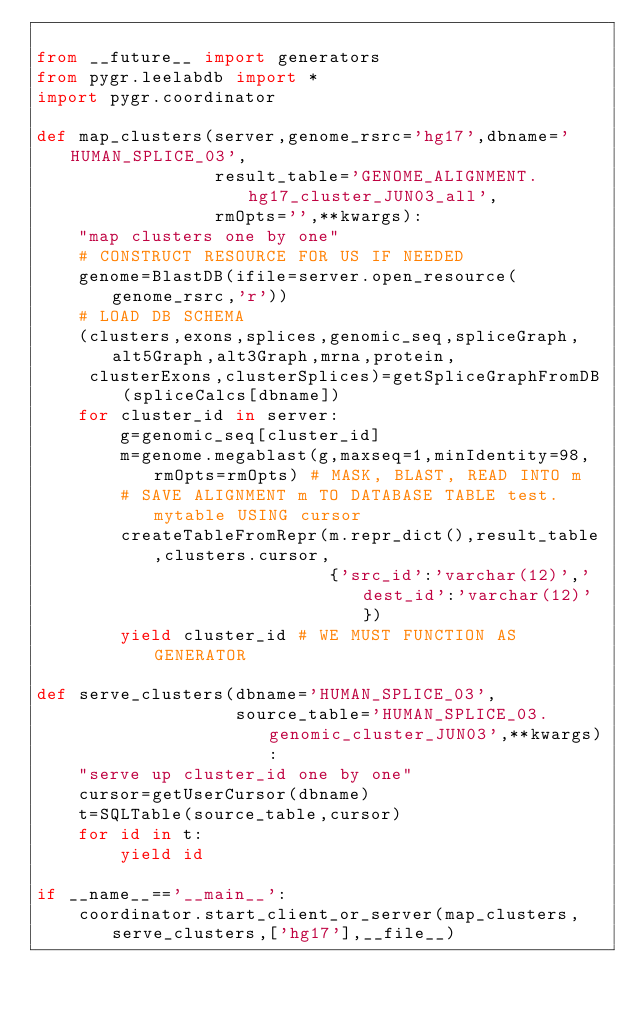<code> <loc_0><loc_0><loc_500><loc_500><_Python_>
from __future__ import generators
from pygr.leelabdb import *
import pygr.coordinator

def map_clusters(server,genome_rsrc='hg17',dbname='HUMAN_SPLICE_03',
                 result_table='GENOME_ALIGNMENT.hg17_cluster_JUN03_all',
                 rmOpts='',**kwargs):
    "map clusters one by one"
    # CONSTRUCT RESOURCE FOR US IF NEEDED
    genome=BlastDB(ifile=server.open_resource(genome_rsrc,'r'))
    # LOAD DB SCHEMA
    (clusters,exons,splices,genomic_seq,spliceGraph,alt5Graph,alt3Graph,mrna,protein,
     clusterExons,clusterSplices)=getSpliceGraphFromDB(spliceCalcs[dbname])
    for cluster_id in server:
        g=genomic_seq[cluster_id]
        m=genome.megablast(g,maxseq=1,minIdentity=98,rmOpts=rmOpts) # MASK, BLAST, READ INTO m
        # SAVE ALIGNMENT m TO DATABASE TABLE test.mytable USING cursor
        createTableFromRepr(m.repr_dict(),result_table,clusters.cursor,
                            {'src_id':'varchar(12)','dest_id':'varchar(12)'})
        yield cluster_id # WE MUST FUNCTION AS GENERATOR

def serve_clusters(dbname='HUMAN_SPLICE_03',
                   source_table='HUMAN_SPLICE_03.genomic_cluster_JUN03',**kwargs):
    "serve up cluster_id one by one"
    cursor=getUserCursor(dbname)
    t=SQLTable(source_table,cursor)
    for id in t:
        yield id

if __name__=='__main__':
    coordinator.start_client_or_server(map_clusters,serve_clusters,['hg17'],__file__)
</code> 